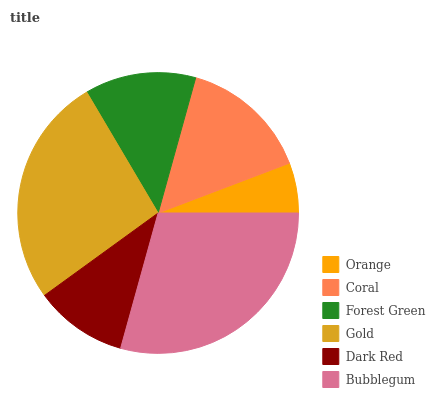Is Orange the minimum?
Answer yes or no. Yes. Is Bubblegum the maximum?
Answer yes or no. Yes. Is Coral the minimum?
Answer yes or no. No. Is Coral the maximum?
Answer yes or no. No. Is Coral greater than Orange?
Answer yes or no. Yes. Is Orange less than Coral?
Answer yes or no. Yes. Is Orange greater than Coral?
Answer yes or no. No. Is Coral less than Orange?
Answer yes or no. No. Is Coral the high median?
Answer yes or no. Yes. Is Forest Green the low median?
Answer yes or no. Yes. Is Gold the high median?
Answer yes or no. No. Is Bubblegum the low median?
Answer yes or no. No. 